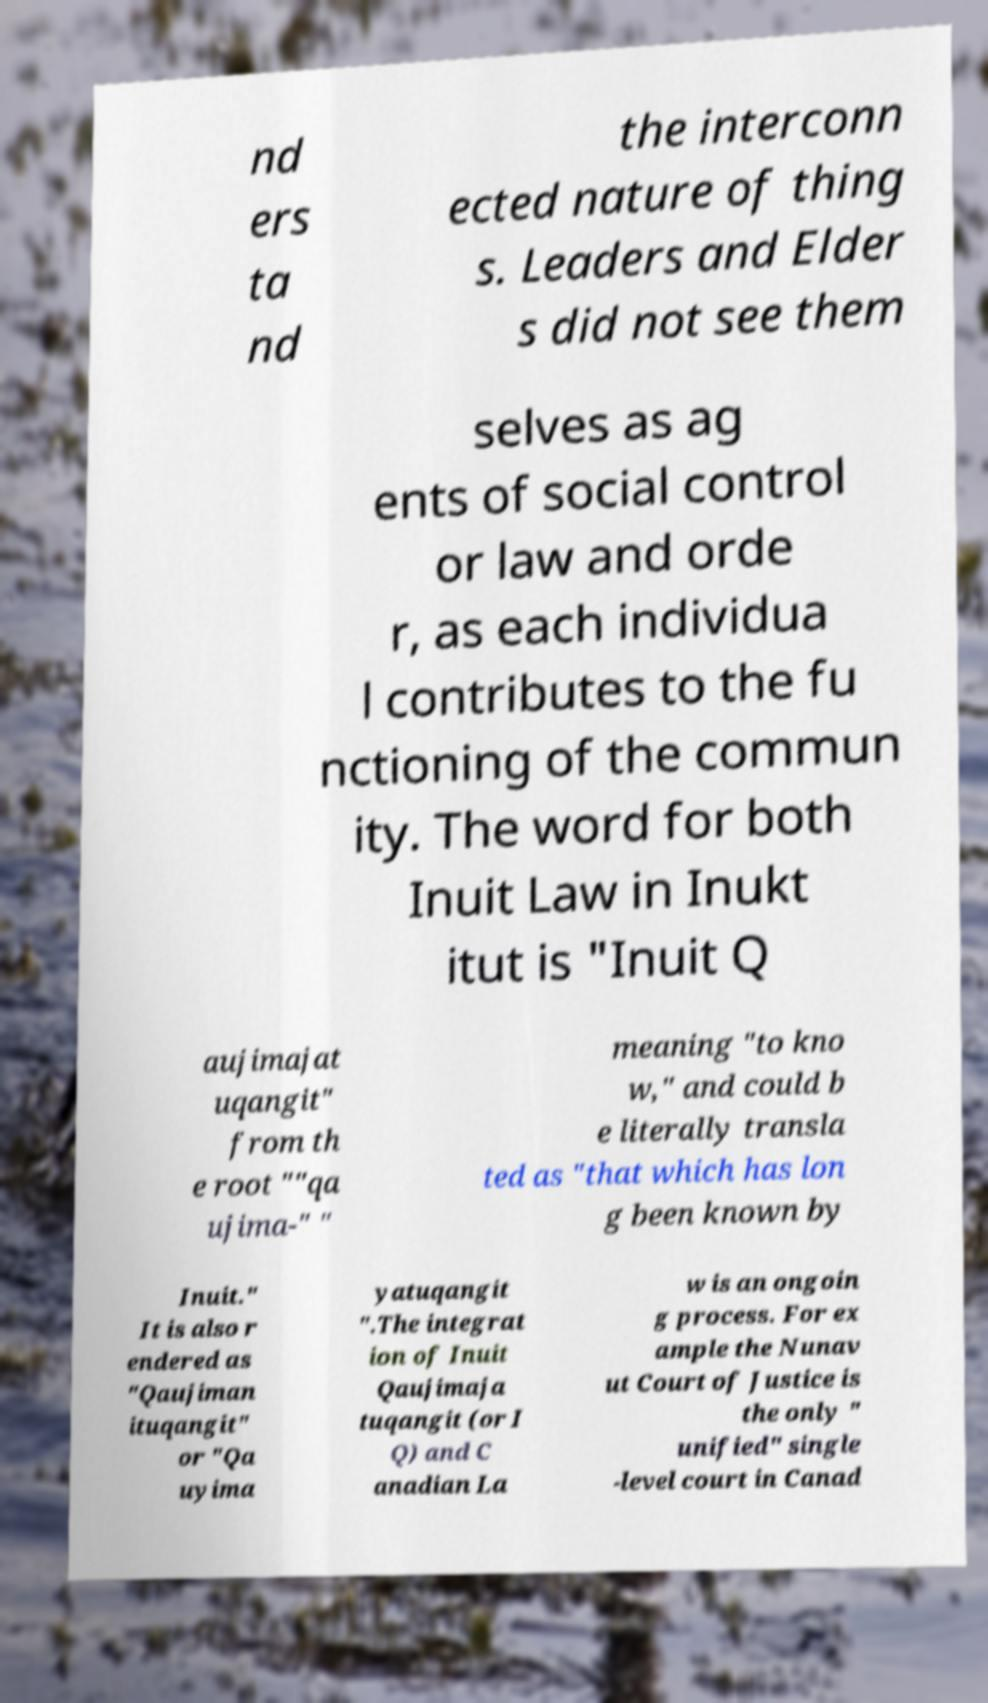There's text embedded in this image that I need extracted. Can you transcribe it verbatim? nd ers ta nd the interconn ected nature of thing s. Leaders and Elder s did not see them selves as ag ents of social control or law and orde r, as each individua l contributes to the fu nctioning of the commun ity. The word for both Inuit Law in Inukt itut is "Inuit Q aujimajat uqangit" from th e root ""qa ujima-" " meaning "to kno w," and could b e literally transla ted as "that which has lon g been known by Inuit." It is also r endered as "Qaujiman ituqangit" or "Qa uyima yatuqangit ".The integrat ion of Inuit Qaujimaja tuqangit (or I Q) and C anadian La w is an ongoin g process. For ex ample the Nunav ut Court of Justice is the only " unified" single -level court in Canad 